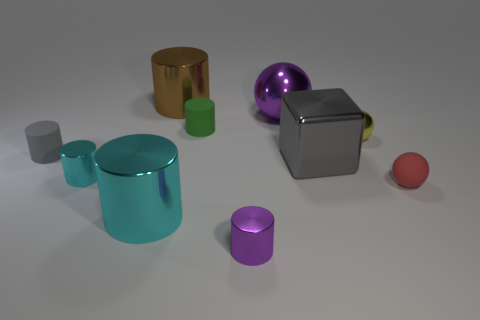Subtract all brown cylinders. How many cylinders are left? 5 Subtract all brown cylinders. How many cylinders are left? 5 Subtract all gray cylinders. Subtract all brown balls. How many cylinders are left? 5 Subtract all cubes. How many objects are left? 9 Add 5 tiny gray rubber cylinders. How many tiny gray rubber cylinders exist? 6 Subtract 1 purple cylinders. How many objects are left? 9 Subtract all large gray rubber cylinders. Subtract all yellow metal spheres. How many objects are left? 9 Add 4 small gray matte cylinders. How many small gray matte cylinders are left? 5 